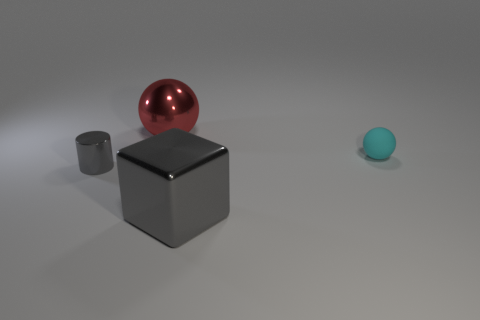Subtract 1 cubes. How many cubes are left? 0 Add 4 brown rubber objects. How many objects exist? 8 Subtract all red spheres. How many spheres are left? 1 Subtract 0 brown balls. How many objects are left? 4 Subtract all cylinders. How many objects are left? 3 Subtract all green cylinders. Subtract all green cubes. How many cylinders are left? 1 Subtract all green cylinders. How many yellow spheres are left? 0 Subtract all tiny yellow metallic blocks. Subtract all cubes. How many objects are left? 3 Add 3 gray cylinders. How many gray cylinders are left? 4 Add 2 gray metallic blocks. How many gray metallic blocks exist? 3 